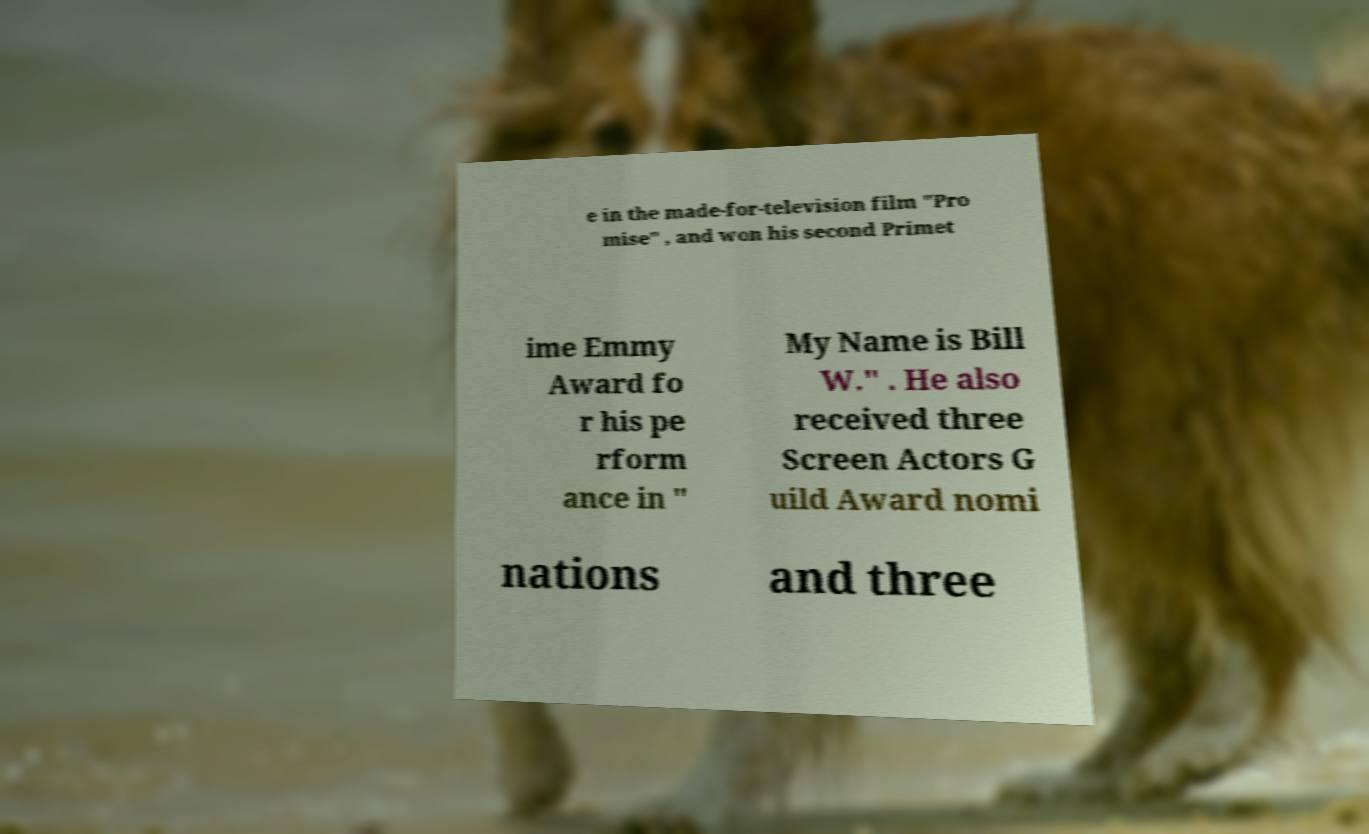What messages or text are displayed in this image? I need them in a readable, typed format. e in the made-for-television film "Pro mise" , and won his second Primet ime Emmy Award fo r his pe rform ance in " My Name is Bill W." . He also received three Screen Actors G uild Award nomi nations and three 